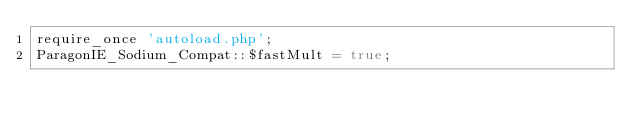<code> <loc_0><loc_0><loc_500><loc_500><_PHP_>require_once 'autoload.php';
ParagonIE_Sodium_Compat::$fastMult = true;
</code> 